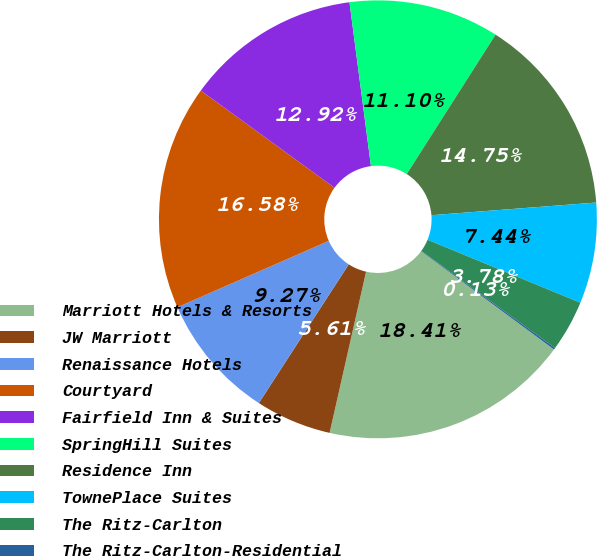Convert chart to OTSL. <chart><loc_0><loc_0><loc_500><loc_500><pie_chart><fcel>Marriott Hotels & Resorts<fcel>JW Marriott<fcel>Renaissance Hotels<fcel>Courtyard<fcel>Fairfield Inn & Suites<fcel>SpringHill Suites<fcel>Residence Inn<fcel>TownePlace Suites<fcel>The Ritz-Carlton<fcel>The Ritz-Carlton-Residential<nl><fcel>18.41%<fcel>5.61%<fcel>9.27%<fcel>16.58%<fcel>12.92%<fcel>11.1%<fcel>14.75%<fcel>7.44%<fcel>3.78%<fcel>0.13%<nl></chart> 